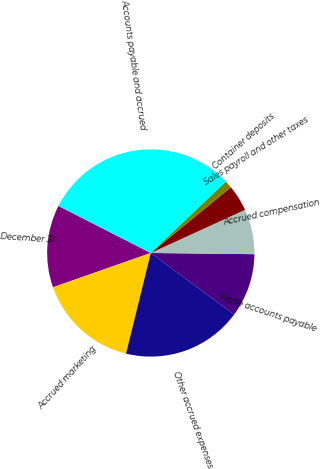Convert chart to OTSL. <chart><loc_0><loc_0><loc_500><loc_500><pie_chart><fcel>December 31<fcel>Accrued marketing<fcel>Other accrued expenses<fcel>Trade accounts payable<fcel>Accrued compensation<fcel>Sales payroll and other taxes<fcel>Container deposits<fcel>Accounts payable and accrued<nl><fcel>12.87%<fcel>15.79%<fcel>18.71%<fcel>9.94%<fcel>7.02%<fcel>4.1%<fcel>1.17%<fcel>30.4%<nl></chart> 